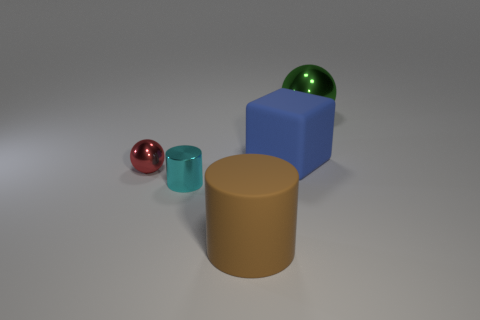Add 4 balls. How many objects exist? 9 Subtract 0 cyan blocks. How many objects are left? 5 Subtract all cylinders. How many objects are left? 3 Subtract 1 cylinders. How many cylinders are left? 1 Subtract all gray blocks. Subtract all yellow spheres. How many blocks are left? 1 Subtract all brown blocks. How many blue cylinders are left? 0 Subtract all cylinders. Subtract all cyan metal cylinders. How many objects are left? 2 Add 3 large shiny balls. How many large shiny balls are left? 4 Add 4 purple things. How many purple things exist? 4 